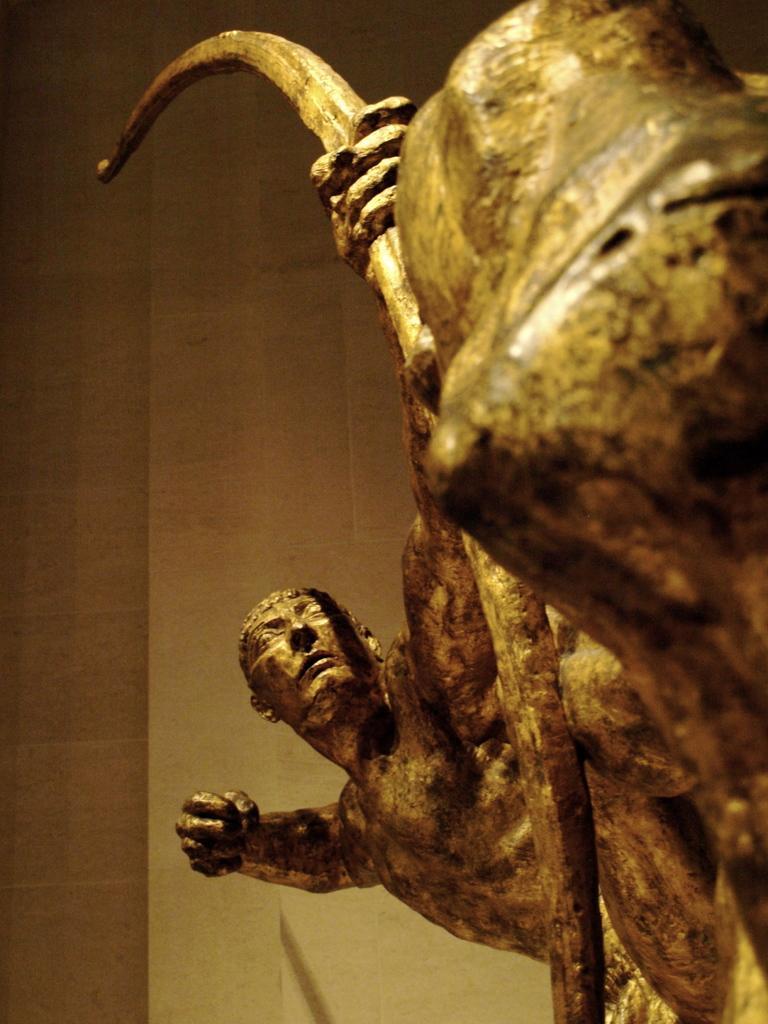Please provide a concise description of this image. In the picture i can see a sculpture of a person who is holding archer in his hands. 